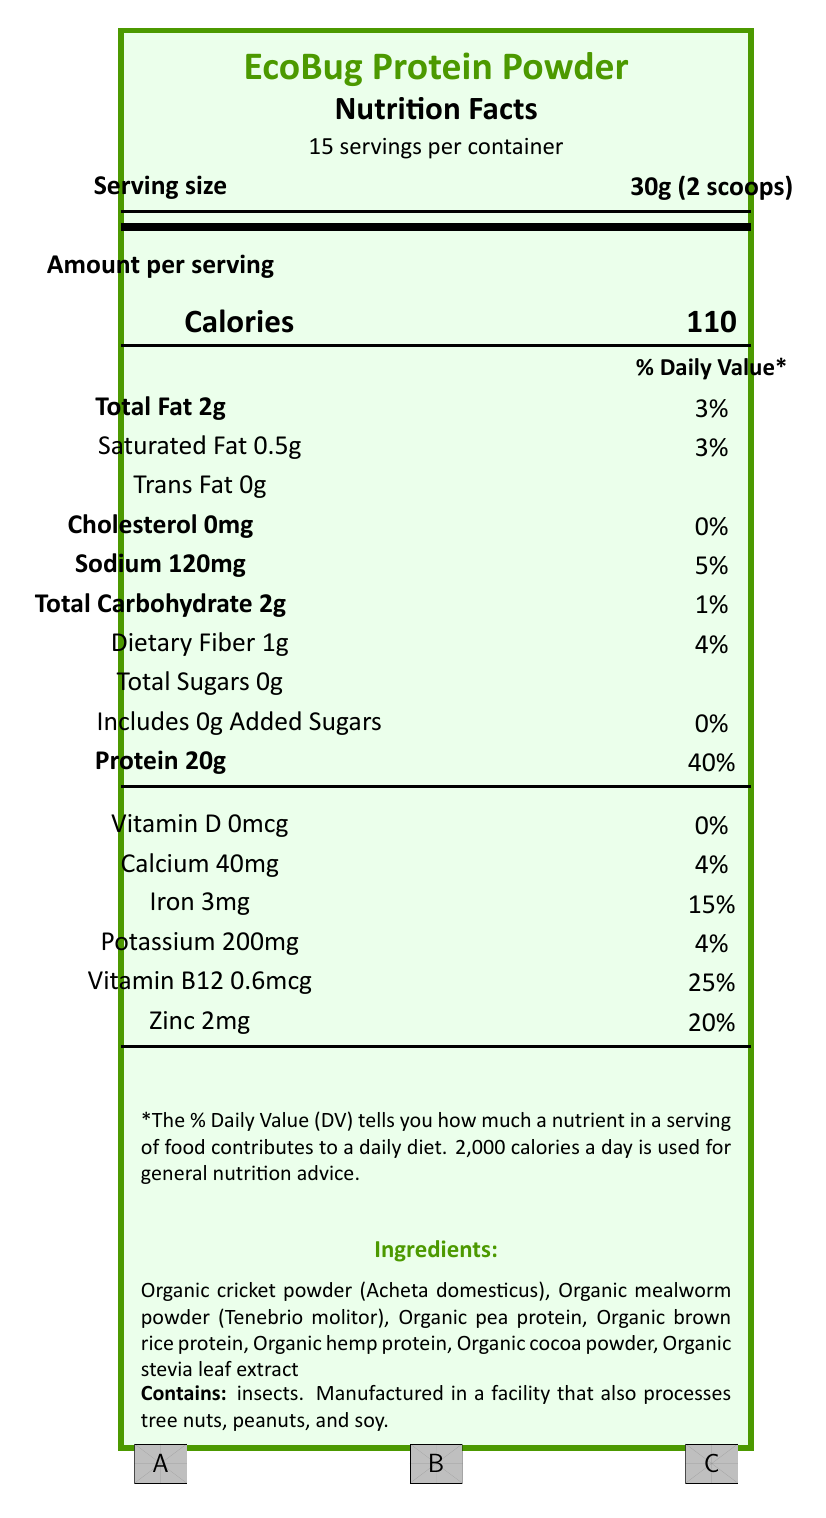what is the serving size of EcoBug Protein Powder? The serving size is indicated next to the heading "Serving size" near the top of the document.
Answer: 30g (2 scoops) how many servings are there per container? The number of servings per container is stated near the top of the document, directly below the product name.
Answer: 15 how many calories are there per serving? The number of calories per serving is listed under the "Amount per serving" section, specified as "Calories 110".
Answer: 110 how much protein is in one serving? Under the "Amount per serving" section, "Protein 20g" is listed along with its % Daily Value.
Answer: 20g what percentage of the daily value of sodium does one serving contain? Next to "Sodium 120mg", the document lists "5%" as the daily value percentage.
Answer: 5% which ingredient is listed first in the ingredients list? The ingredients list starts with "Organic cricket powder (Acheta domesticus)".
Answer: Organic cricket powder (Acheta domesticus) what certifications does EcoBug Protein Powder have? Three certifications are mentioned at the bottom of the document: "USDA Organic", "Non-GMO Project Verified", and "Rainforest Alliance Certified".
Answer: USDA Organic, Non-GMO Project Verified, Rainforest Alliance Certified which of the following nutrients has zero content per serving? A. Saturated Fat B. Cholesterol C. Dietary Fiber The "Cholesterol" section lists "0mg" and "0%".
Answer: B. Cholesterol what is the daily value percentage of iron per serving of EcoBug Protein Powder? A. 4% B. 15% C. 20% D. 25% The daily value for iron is listed as "15%", next to "Iron 3mg".
Answer: B. 15% does the EcoBug Protein Powder contain any added sugars? It states "Includes 0g Added Sugars" and "0%" under the "Total Sugars" section.
Answer: No which sustainability benefit is NOT listed in the document? A. Supports pollinator-friendly farming practices B. Reduces pressure on wild insect populations C. Enhances soil fertility D. Promotes sustainable agriculture and circular economy The document lists A, B, and D in the sustainability info section, but not C.
Answer: C. Enhances soil fertility is there any allergen information provided? The allergen information states, "Contains insects. Manufactured in a facility that also processes tree nuts, peanuts, and soy."
Answer: Yes does the document mention any ecological benefits of using the product? The document includes several ecological benefits such as "Supports pollinator-friendly farming practices" and "Reduces pressure on wild insect populations".
Answer: Yes summarize the entire document or the main idea. The document mainly focuses on the nutritional content, sustainability and ecological benefits of the EcoBug Protein Powder, made from sustainably harvested insects.
Answer: The document provides detailed nutritional information for EcoBug Protein Powder, including serving size, calories, fats, cholesterol, sodium, carbohydrates, protein, vitamins, and minerals. It lists ingredients, allergen info, certifications, sustainability details, ecological benefits, and a conservation statement. what is the source of protein in EcoBug Protein Powder? The document does not specify the source of each protein component within the ingredients list explicitly. The answer "Cricket and mealworm powders, pea protein, brown rice protein, and hemp protein are listed as ingredients, but without any specific proportion or main source data." is inferred but not directly stated.
Answer: Cannot be determined 